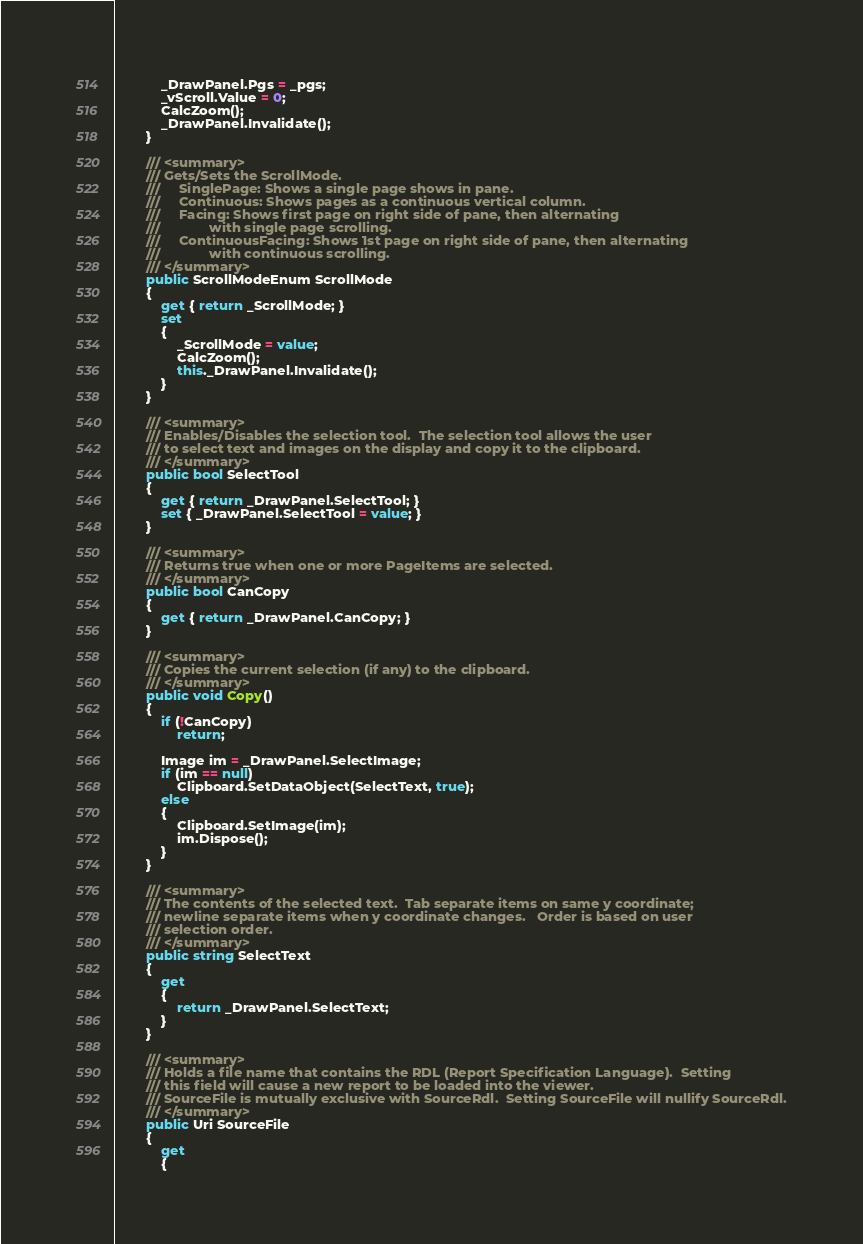<code> <loc_0><loc_0><loc_500><loc_500><_C#_>            _DrawPanel.Pgs = _pgs;
            _vScroll.Value = 0;
            CalcZoom();
            _DrawPanel.Invalidate();
        }

        /// <summary>
        /// Gets/Sets the ScrollMode.  
        ///		SinglePage: Shows a single page shows in pane.
        ///		Continuous: Shows pages as a continuous vertical column.
        ///		Facing: Shows first page on right side of pane, then alternating
        ///				with single page scrolling.
        ///		ContinuousFacing: Shows 1st page on right side of pane, then alternating 
        ///				with continuous scrolling.
        /// </summary>
        public ScrollModeEnum ScrollMode
        {
            get { return _ScrollMode; }
            set
            {
                _ScrollMode = value;
                CalcZoom();
                this._DrawPanel.Invalidate();
            }
        }

        /// <summary>
        /// Enables/Disables the selection tool.  The selection tool allows the user
        /// to select text and images on the display and copy it to the clipboard.
        /// </summary>
        public bool SelectTool
        {
            get { return _DrawPanel.SelectTool; }
            set { _DrawPanel.SelectTool = value; }
        }

        /// <summary>
        /// Returns true when one or more PageItems are selected.
        /// </summary>
        public bool CanCopy
        {
            get { return _DrawPanel.CanCopy; }
        }

        /// <summary>
        /// Copies the current selection (if any) to the clipboard.
        /// </summary>
        public void Copy()
        {
            if (!CanCopy)
                return;

            Image im = _DrawPanel.SelectImage;
            if (im == null)
                Clipboard.SetDataObject(SelectText, true);
            else
            {
                Clipboard.SetImage(im);
                im.Dispose();
            }
        }

        /// <summary>
        /// The contents of the selected text.  Tab separate items on same y coordinate;
        /// newline separate items when y coordinate changes.   Order is based on user
        /// selection order.
        /// </summary>
        public string SelectText
        {
            get
            {
                return _DrawPanel.SelectText;
            }
        }

        /// <summary>
        /// Holds a file name that contains the RDL (Report Specification Language).  Setting
        /// this field will cause a new report to be loaded into the viewer.
        /// SourceFile is mutually exclusive with SourceRdl.  Setting SourceFile will nullify SourceRdl.
        /// </summary>
        public Uri SourceFile
        {
            get
            {</code> 